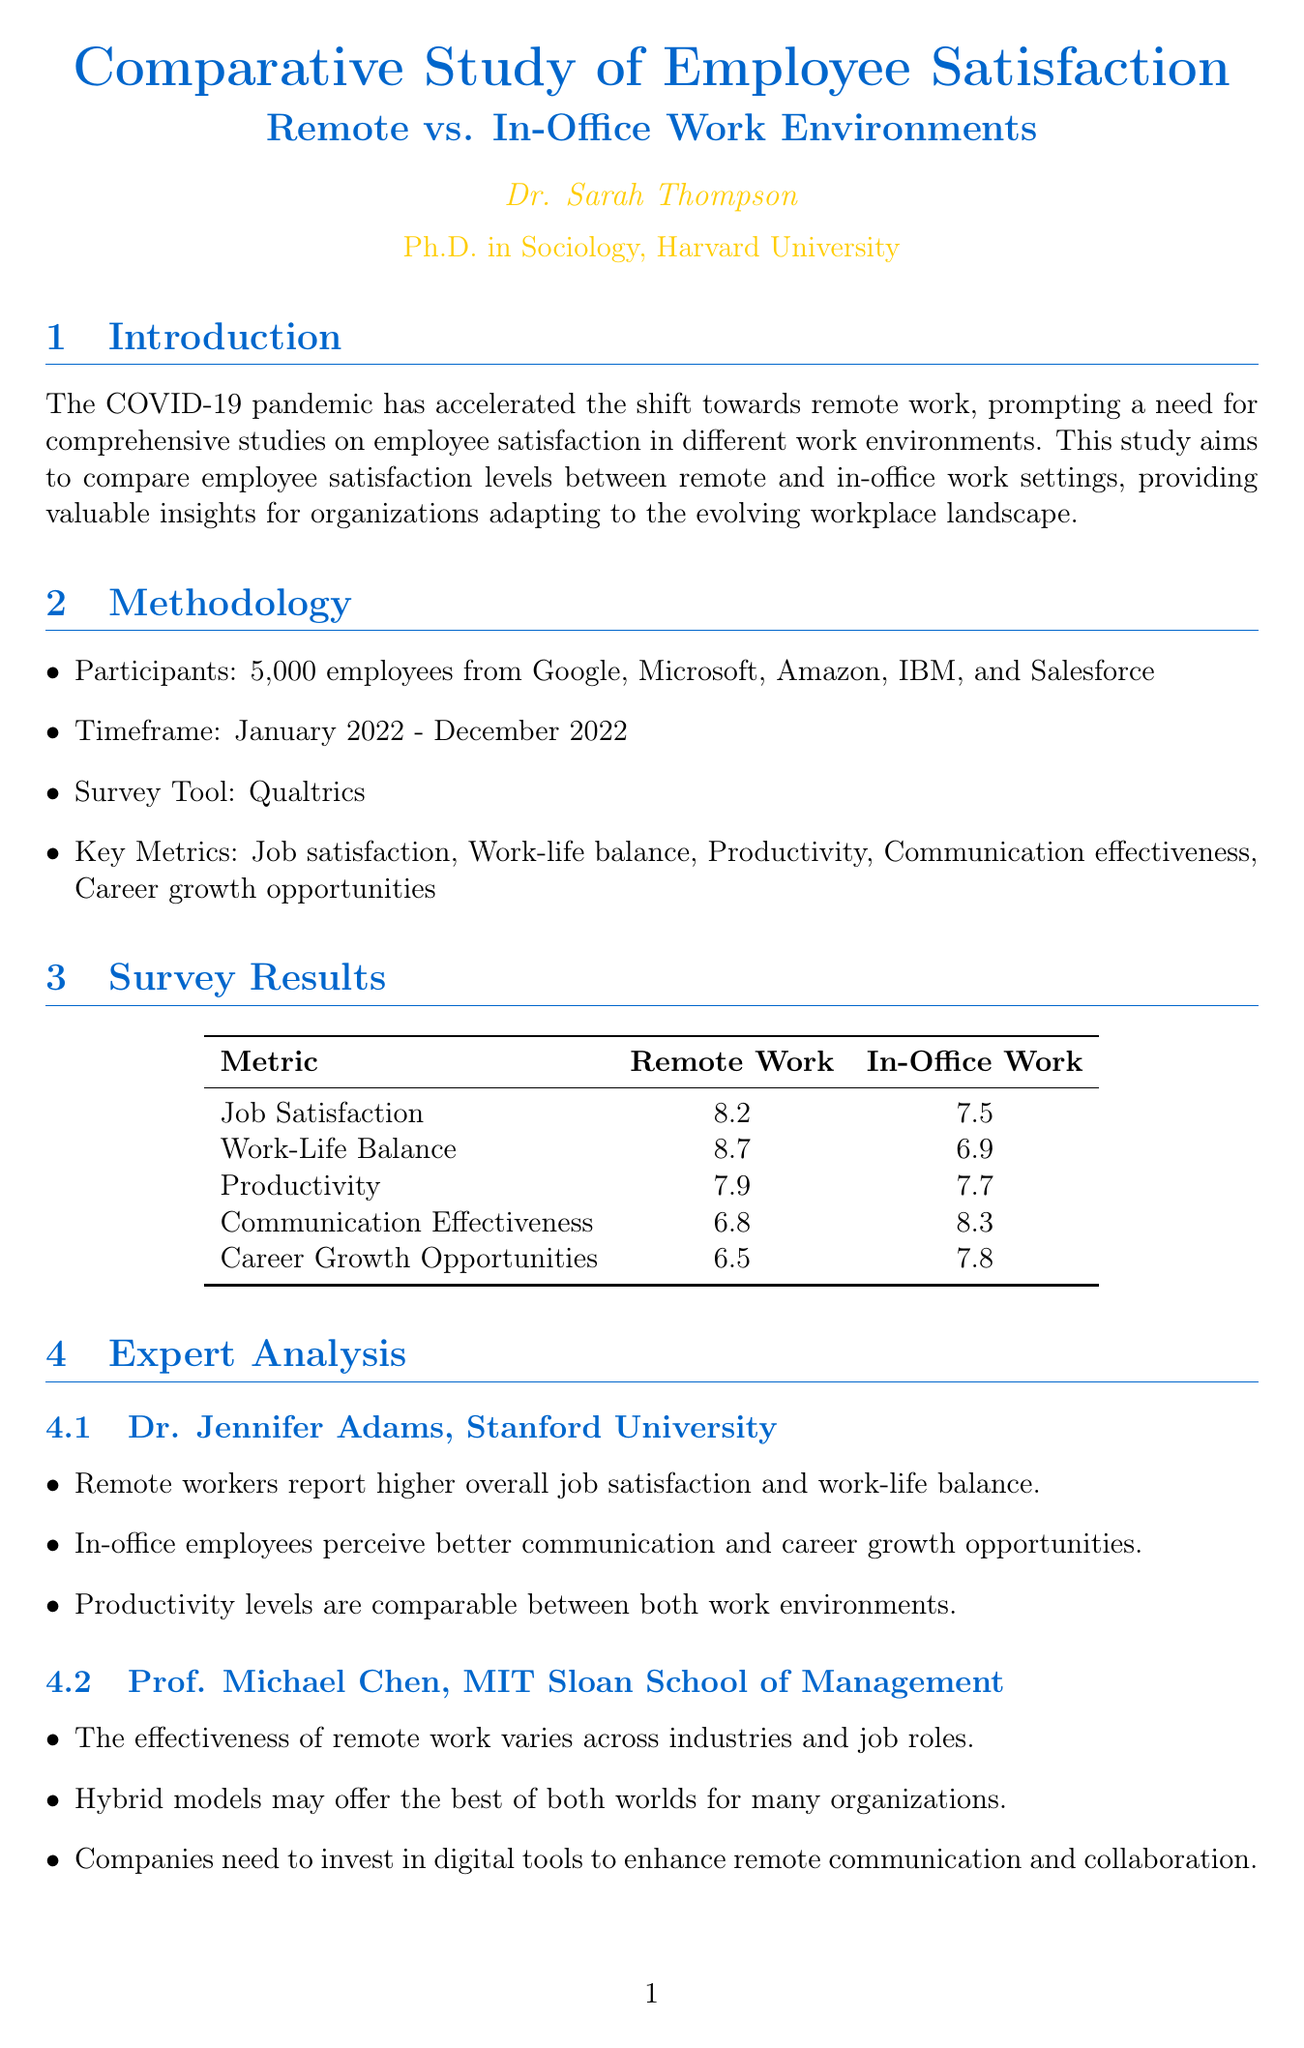what is the primary objective of the study? The primary objective is stated in the introduction as comparing employee satisfaction levels between remote and in-office work settings.
Answer: to compare employee satisfaction levels between remote and in-office work settings how many participants were surveyed? The document provides information on the number of survey participants in the methodology section.
Answer: 5000 what was the score for job satisfaction in remote work? The score for job satisfaction for remote work is found in the survey results section under remote work metrics.
Answer: 8.2 which expert is affiliated with Stanford University? The experts listed in the expert analysis section show Dr. Jennifer Adams is affiliated with Stanford University.
Answer: Dr. Jennifer Adams what significant results did Atlassian achieve with their Team Anywhere policy? The case studies section highlights the results achieved by Atlassian, focusing on employee retention and productivity.
Answer: 20% increase in employee retention and 15% boost in productivity what recommendation is made regarding technology investment? The recommendations section includes specific suggestions for organizations that emphasize the role of technology in remote work.
Answer: Invest in technology and training to support effective remote collaboration which industry uses a rotational hybrid model according to the case studies? The case studies section identifies the finance sector as using a rotational hybrid model with the associated company.
Answer: JPMorgan Chase what is one key observation by Prof. Michael Chen? The expert analysis section for Prof. Michael Chen lists key observations, including the effectiveness of remote work varying across industries.
Answer: The effectiveness of remote work varies across industries and job roles 